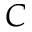Convert formula to latex. <formula><loc_0><loc_0><loc_500><loc_500>C</formula> 